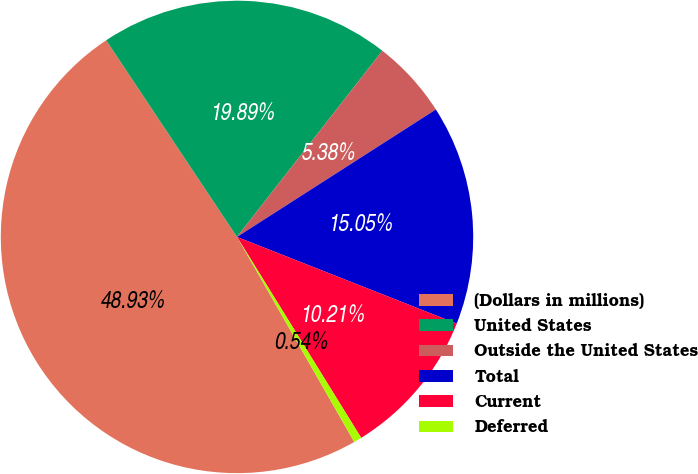Convert chart. <chart><loc_0><loc_0><loc_500><loc_500><pie_chart><fcel>(Dollars in millions)<fcel>United States<fcel>Outside the United States<fcel>Total<fcel>Current<fcel>Deferred<nl><fcel>48.93%<fcel>19.89%<fcel>5.38%<fcel>15.05%<fcel>10.21%<fcel>0.54%<nl></chart> 